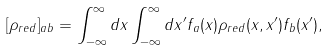<formula> <loc_0><loc_0><loc_500><loc_500>[ \rho _ { r e d } ] _ { a b } = \int _ { - \infty } ^ { \infty } d x \int _ { - \infty } ^ { \infty } d x ^ { \prime } f _ { a } ( x ) \rho _ { r e d } ( x , x ^ { \prime } ) f _ { b } ( x ^ { \prime } ) ,</formula> 